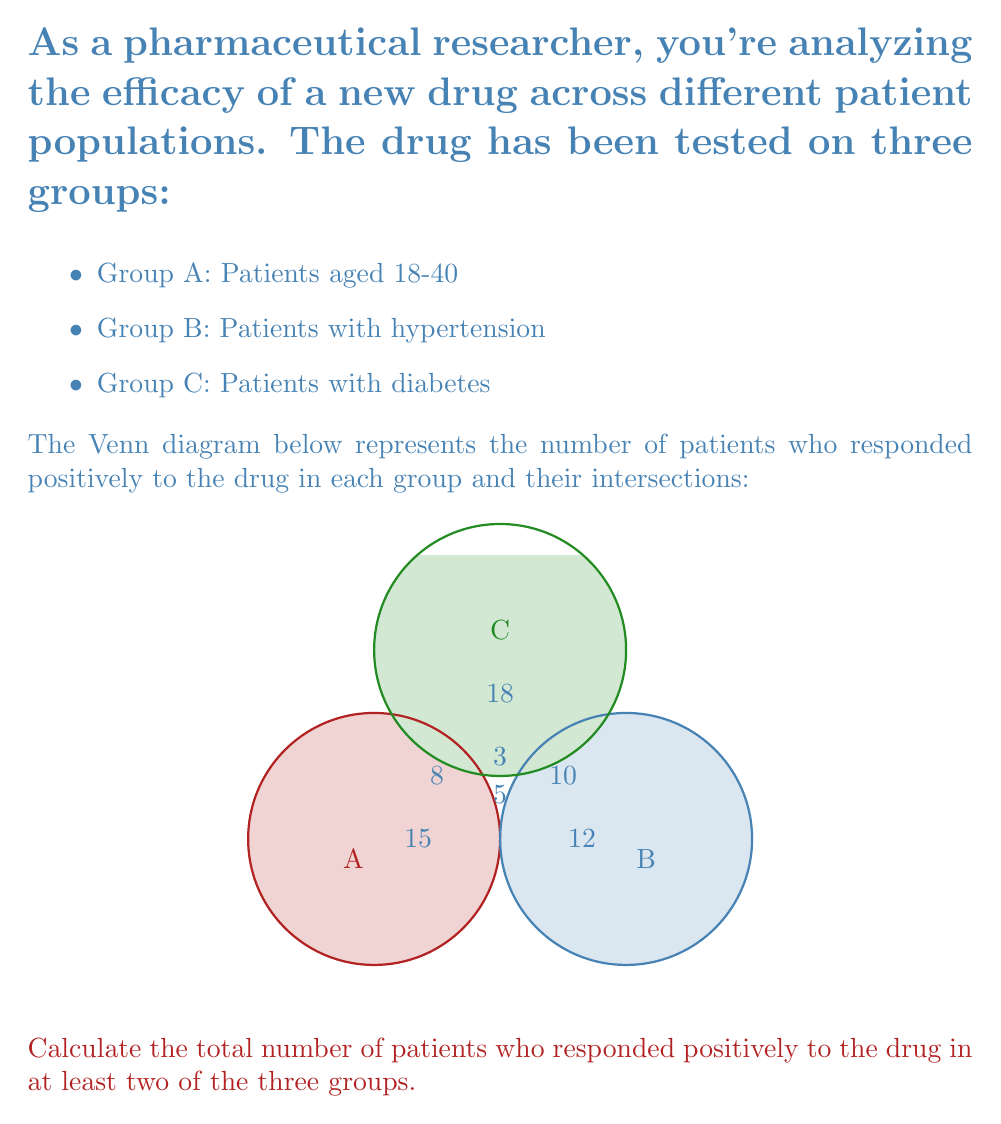What is the answer to this math problem? Let's approach this step-by-step:

1) First, we need to understand what the question is asking. We're looking for patients who responded positively in at least two groups, which means we need to find the sum of all intersections.

2) From the Venn diagram, we can identify the following intersections:
   - A ∩ B (not including A ∩ B ∩ C): 5
   - B ∩ C (not including A ∩ B ∩ C): 10
   - A ∩ C (not including A ∩ B ∩ C): 8
   - A ∩ B ∩ C: 3

3) Now, let's set up our calculation:
   $$(A \cap B) + (B \cap C) + (A \cap C) + (A \cap B \cap C)$$

4) Substituting the values:
   $$5 + 10 + 8 + 3 = 26$$

5) Therefore, the total number of patients who responded positively to the drug in at least two of the three groups is 26.

This information is crucial for developing marketing strategies, as it shows the overlap in drug efficacy across different patient populations, which can be used to target specific groups or highlight the drug's versatility.
Answer: 26 patients 